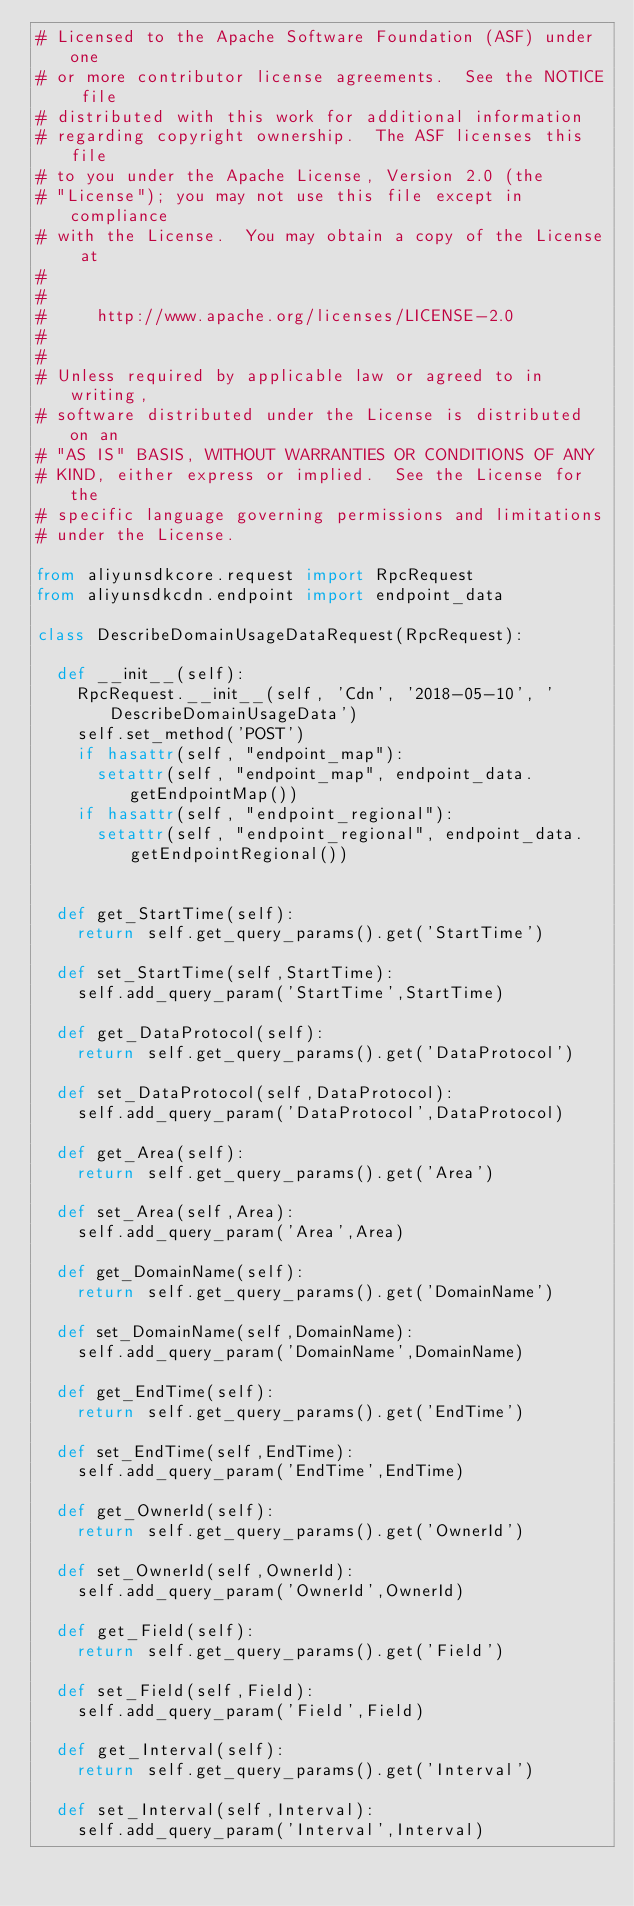<code> <loc_0><loc_0><loc_500><loc_500><_Python_># Licensed to the Apache Software Foundation (ASF) under one
# or more contributor license agreements.  See the NOTICE file
# distributed with this work for additional information
# regarding copyright ownership.  The ASF licenses this file
# to you under the Apache License, Version 2.0 (the
# "License"); you may not use this file except in compliance
# with the License.  You may obtain a copy of the License at
#
#
#     http://www.apache.org/licenses/LICENSE-2.0
#
#
# Unless required by applicable law or agreed to in writing,
# software distributed under the License is distributed on an
# "AS IS" BASIS, WITHOUT WARRANTIES OR CONDITIONS OF ANY
# KIND, either express or implied.  See the License for the
# specific language governing permissions and limitations
# under the License.

from aliyunsdkcore.request import RpcRequest
from aliyunsdkcdn.endpoint import endpoint_data

class DescribeDomainUsageDataRequest(RpcRequest):

	def __init__(self):
		RpcRequest.__init__(self, 'Cdn', '2018-05-10', 'DescribeDomainUsageData')
		self.set_method('POST')
		if hasattr(self, "endpoint_map"):
			setattr(self, "endpoint_map", endpoint_data.getEndpointMap())
		if hasattr(self, "endpoint_regional"):
			setattr(self, "endpoint_regional", endpoint_data.getEndpointRegional())


	def get_StartTime(self):
		return self.get_query_params().get('StartTime')

	def set_StartTime(self,StartTime):
		self.add_query_param('StartTime',StartTime)

	def get_DataProtocol(self):
		return self.get_query_params().get('DataProtocol')

	def set_DataProtocol(self,DataProtocol):
		self.add_query_param('DataProtocol',DataProtocol)

	def get_Area(self):
		return self.get_query_params().get('Area')

	def set_Area(self,Area):
		self.add_query_param('Area',Area)

	def get_DomainName(self):
		return self.get_query_params().get('DomainName')

	def set_DomainName(self,DomainName):
		self.add_query_param('DomainName',DomainName)

	def get_EndTime(self):
		return self.get_query_params().get('EndTime')

	def set_EndTime(self,EndTime):
		self.add_query_param('EndTime',EndTime)

	def get_OwnerId(self):
		return self.get_query_params().get('OwnerId')

	def set_OwnerId(self,OwnerId):
		self.add_query_param('OwnerId',OwnerId)

	def get_Field(self):
		return self.get_query_params().get('Field')

	def set_Field(self,Field):
		self.add_query_param('Field',Field)

	def get_Interval(self):
		return self.get_query_params().get('Interval')

	def set_Interval(self,Interval):
		self.add_query_param('Interval',Interval)</code> 